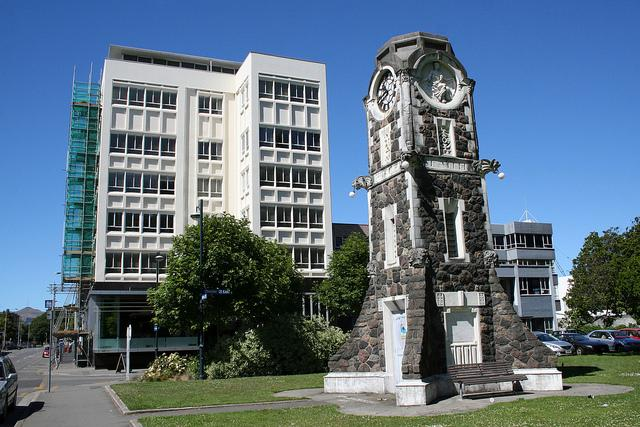How do you know there is work being done on the white building?

Choices:
A) construction workers
B) signs
C) materials
D) scaffolding scaffolding 